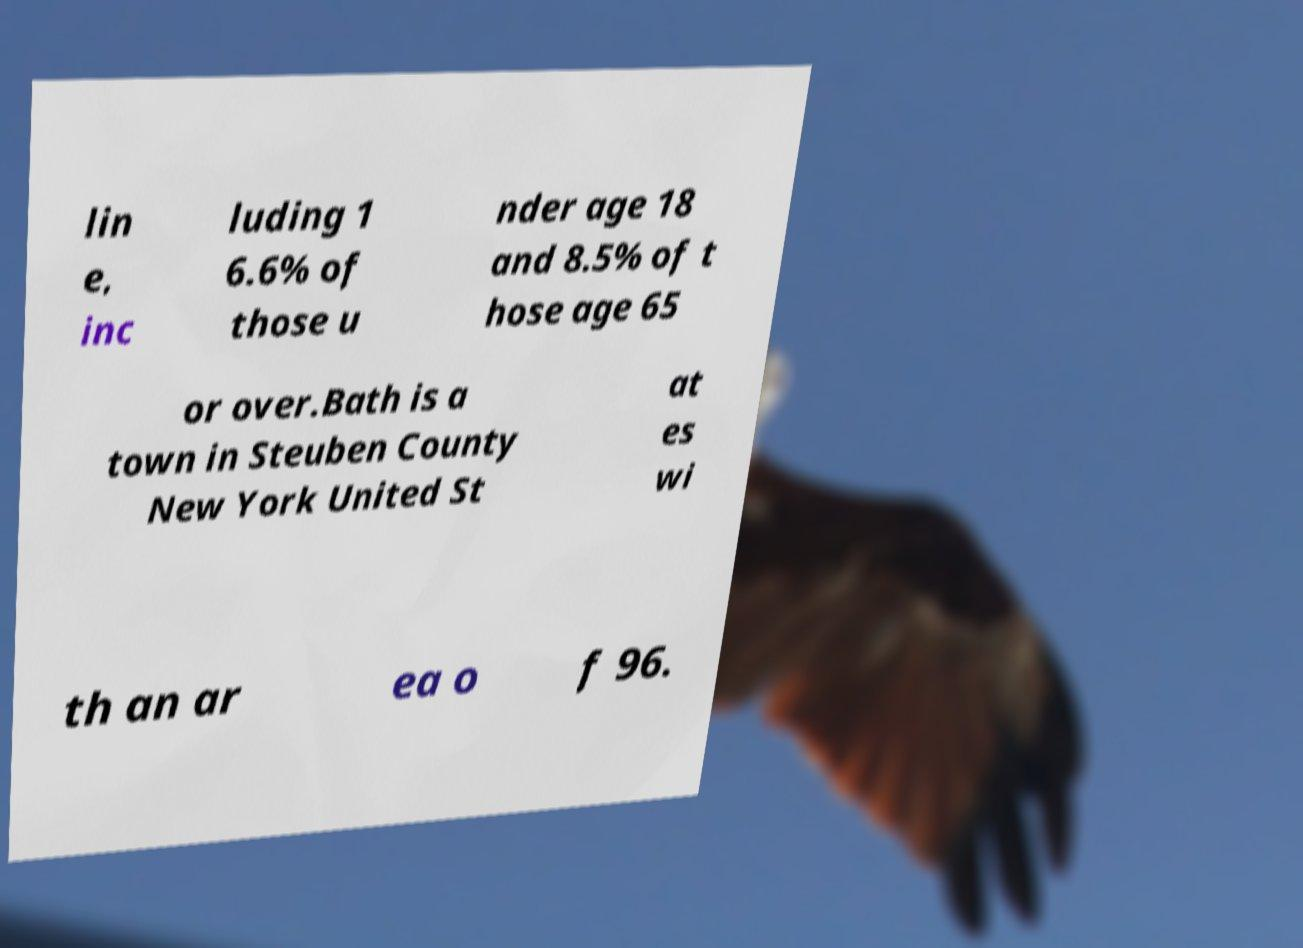I need the written content from this picture converted into text. Can you do that? lin e, inc luding 1 6.6% of those u nder age 18 and 8.5% of t hose age 65 or over.Bath is a town in Steuben County New York United St at es wi th an ar ea o f 96. 